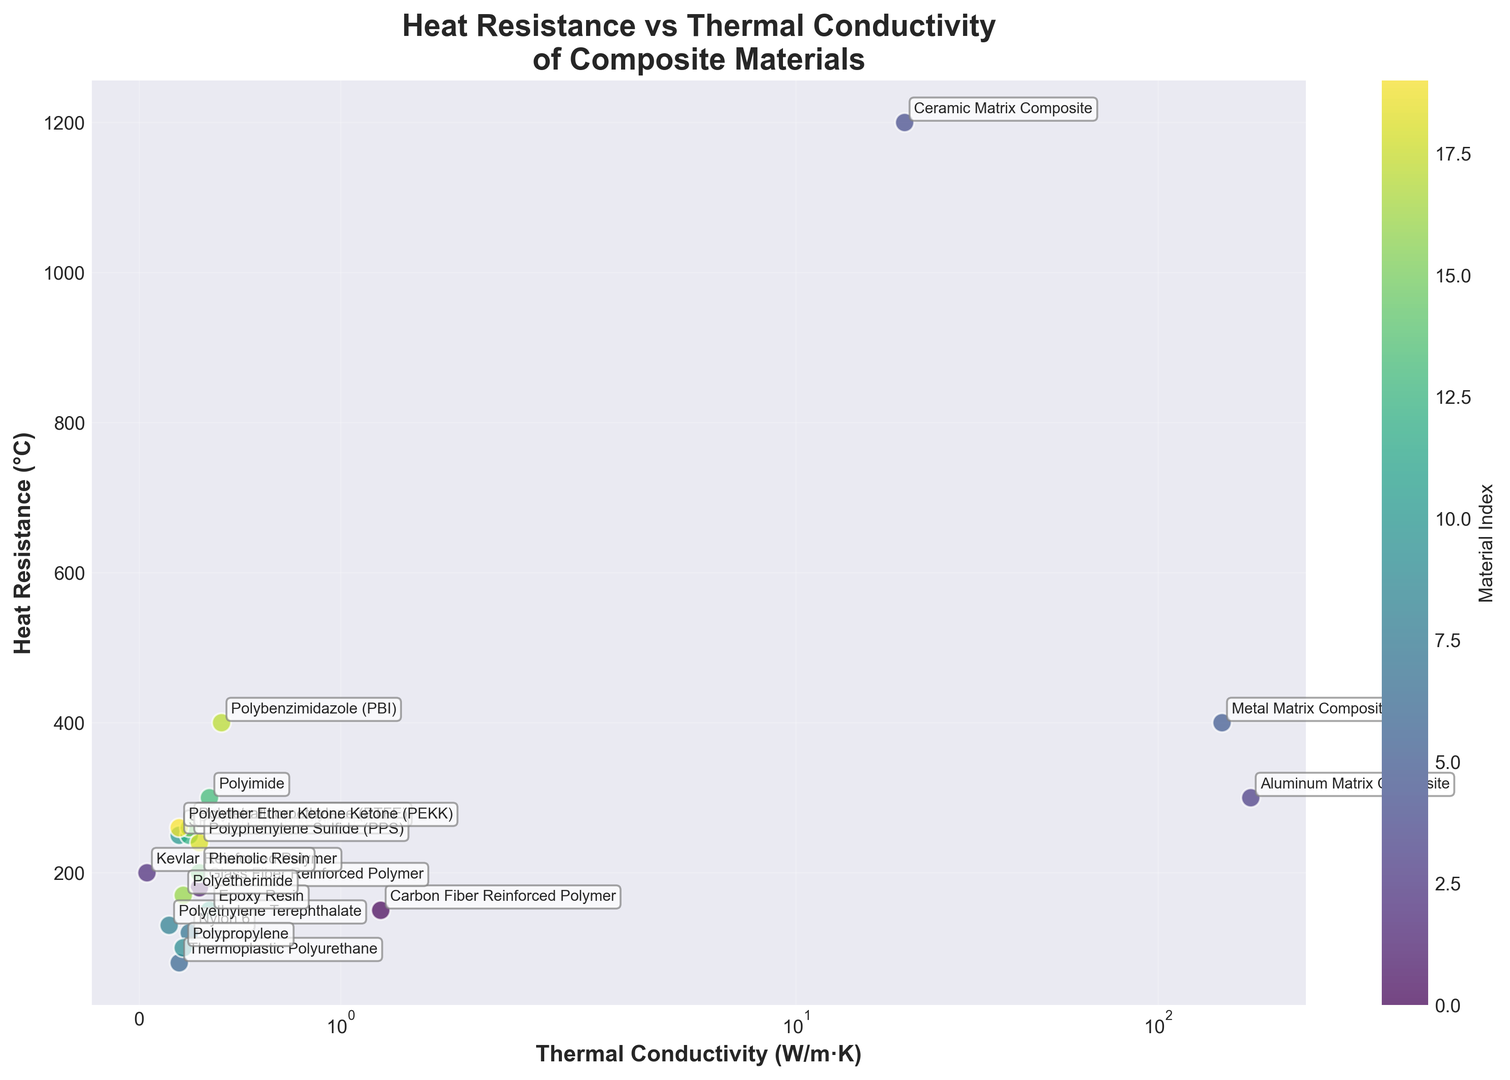Which material has the highest heat resistance? Looking at the y-axis (Heat Resistance in °C), the material that reaches the highest point is Ceramic Matrix Composite.
Answer: Ceramic Matrix Composite Which material has the lowest thermal conductivity? By examining the x-axis (Thermal Conductivity in W/m·K), the material that is positioned farthest to the left is Kevlar Reinforced Polymer.
Answer: Kevlar Reinforced Polymer How does the heat resistance of Polyetheretherketone (PEEK) compare to Polyetherimide? Both PEEK and Polyetherimide are annotated on the plot. Examining their positions, PEEK has a heat resistance of 250°C, while Polyetherimide has a heat resistance of 170°C.
Answer: PEEK has higher heat resistance than Polyetherimide Identify the materials that have both heat resistance greater than 200°C and thermal conductivity less than 1 W/m·K. By visually inspecting the top-left quadrant of the plot, the materials meeting both criteria are Kevlar Reinforced Polymer and Polytetrafluoroethylene (PTFE).
Answer: Kevlar Reinforced Polymer, Polytetrafluoroethylene (PTFE) Are there any materials with a thermal conductivity above 100 W/m·K and heat resistance above 300°C? Checking the top-right quadrant of the plot, we spot Aluminum Matrix Composite with 300°C heat resistance and 180 W/m·K thermal conductivity, and Metal Matrix Composite with 400°C heat resistance and 150 W/m·K thermal conductivity.
Answer: Aluminum Matrix Composite, Metal Matrix Composite What's the average heat resistance of materials with thermal conductivity less than 1 W/m·K? Identify materials with thermal conductivity under 1 W/m·K (Kevlar Reinforced Polymer, Glass Fiber Reinforced Polymer, Thermoplastic Polyurethane, Nylon 6, Polyethylene Terephthalate, Polypropylene, Silicone Rubber, Epoxy Resin, Polyetheretherketone, Polyimide, Phenolic Resin, Polytetrafluoroethylene, Polyetherimide, Polyphenylene Sulfide, Polyether Ether Ketone Ketone) and calculate the average heat resistance:
(200 + 180 + 80 + 120 + 130 + 100 + 250 + 150 + 300 + 200 + 260 + 170 + 240 + 260) / 14 ≈ 187.14°C.
Answer: 187.14°C Which material has similar heat resistance but lower thermal conductivity compared to Epoxy Resin? Epoxy Resin has a heat resistance of 150°C and thermal conductivity of 0.35 W/m·K. Upon examining nearby points, Polyimide with a similar heat resistance (300°C) but lower thermal conductivity (0.35 W/m·K) fits the criteria.
Answer: Polyimide 